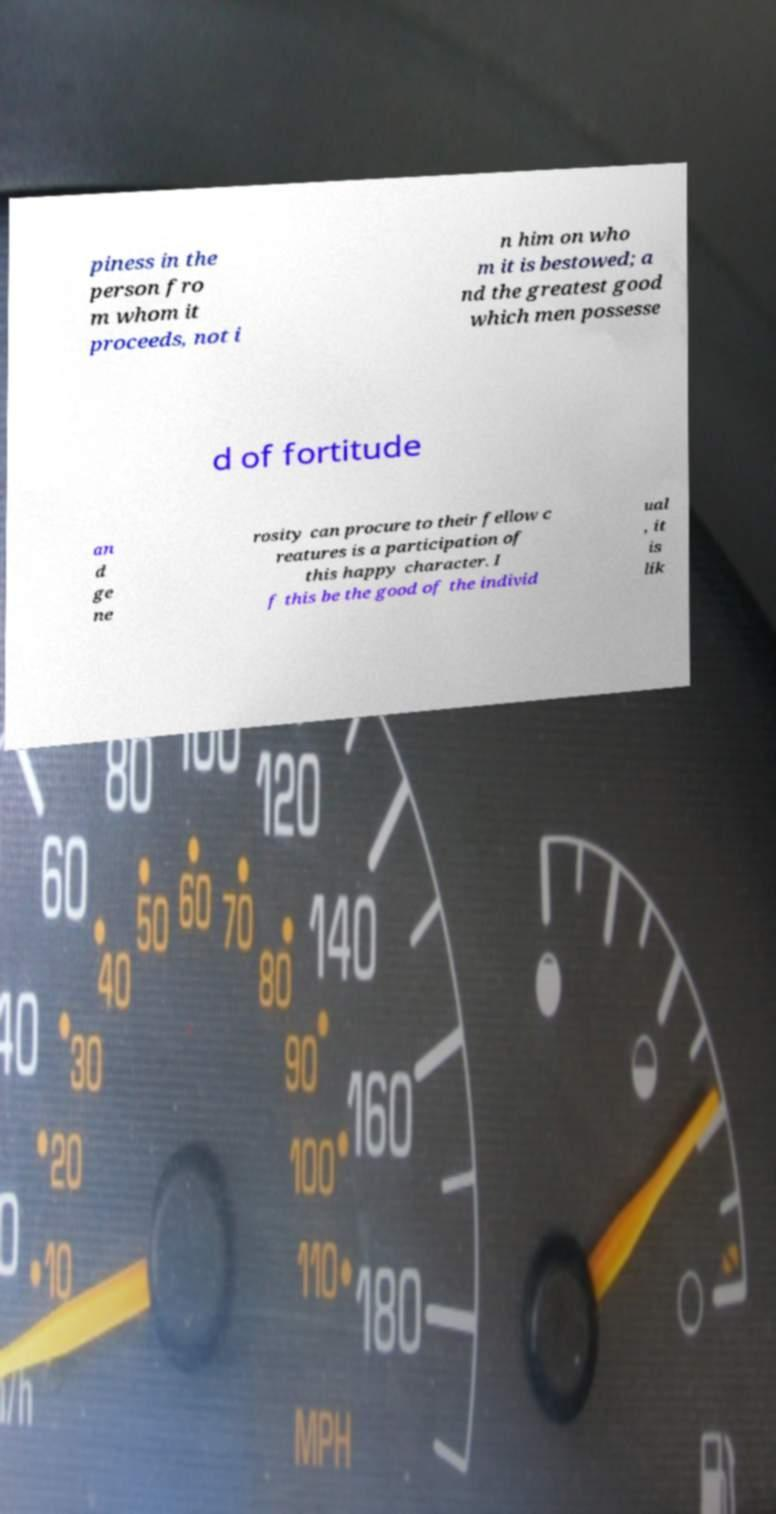I need the written content from this picture converted into text. Can you do that? piness in the person fro m whom it proceeds, not i n him on who m it is bestowed; a nd the greatest good which men possesse d of fortitude an d ge ne rosity can procure to their fellow c reatures is a participation of this happy character. I f this be the good of the individ ual , it is lik 